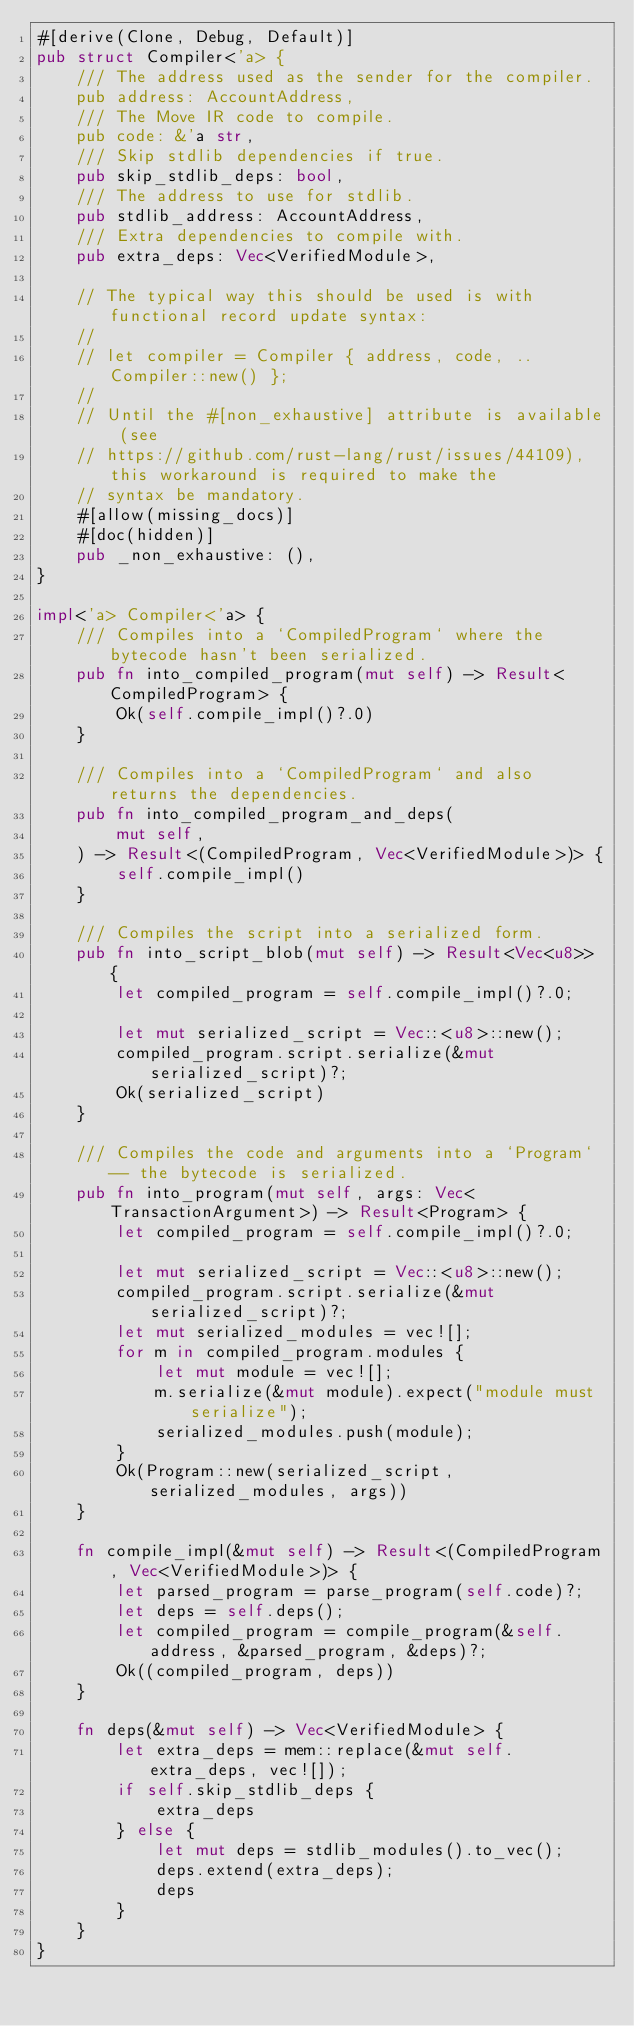<code> <loc_0><loc_0><loc_500><loc_500><_Rust_>#[derive(Clone, Debug, Default)]
pub struct Compiler<'a> {
    /// The address used as the sender for the compiler.
    pub address: AccountAddress,
    /// The Move IR code to compile.
    pub code: &'a str,
    /// Skip stdlib dependencies if true.
    pub skip_stdlib_deps: bool,
    /// The address to use for stdlib.
    pub stdlib_address: AccountAddress,
    /// Extra dependencies to compile with.
    pub extra_deps: Vec<VerifiedModule>,

    // The typical way this should be used is with functional record update syntax:
    //
    // let compiler = Compiler { address, code, ..Compiler::new() };
    //
    // Until the #[non_exhaustive] attribute is available (see
    // https://github.com/rust-lang/rust/issues/44109), this workaround is required to make the
    // syntax be mandatory.
    #[allow(missing_docs)]
    #[doc(hidden)]
    pub _non_exhaustive: (),
}

impl<'a> Compiler<'a> {
    /// Compiles into a `CompiledProgram` where the bytecode hasn't been serialized.
    pub fn into_compiled_program(mut self) -> Result<CompiledProgram> {
        Ok(self.compile_impl()?.0)
    }

    /// Compiles into a `CompiledProgram` and also returns the dependencies.
    pub fn into_compiled_program_and_deps(
        mut self,
    ) -> Result<(CompiledProgram, Vec<VerifiedModule>)> {
        self.compile_impl()
    }

    /// Compiles the script into a serialized form.
    pub fn into_script_blob(mut self) -> Result<Vec<u8>> {
        let compiled_program = self.compile_impl()?.0;

        let mut serialized_script = Vec::<u8>::new();
        compiled_program.script.serialize(&mut serialized_script)?;
        Ok(serialized_script)
    }

    /// Compiles the code and arguments into a `Program` -- the bytecode is serialized.
    pub fn into_program(mut self, args: Vec<TransactionArgument>) -> Result<Program> {
        let compiled_program = self.compile_impl()?.0;

        let mut serialized_script = Vec::<u8>::new();
        compiled_program.script.serialize(&mut serialized_script)?;
        let mut serialized_modules = vec![];
        for m in compiled_program.modules {
            let mut module = vec![];
            m.serialize(&mut module).expect("module must serialize");
            serialized_modules.push(module);
        }
        Ok(Program::new(serialized_script, serialized_modules, args))
    }

    fn compile_impl(&mut self) -> Result<(CompiledProgram, Vec<VerifiedModule>)> {
        let parsed_program = parse_program(self.code)?;
        let deps = self.deps();
        let compiled_program = compile_program(&self.address, &parsed_program, &deps)?;
        Ok((compiled_program, deps))
    }

    fn deps(&mut self) -> Vec<VerifiedModule> {
        let extra_deps = mem::replace(&mut self.extra_deps, vec![]);
        if self.skip_stdlib_deps {
            extra_deps
        } else {
            let mut deps = stdlib_modules().to_vec();
            deps.extend(extra_deps);
            deps
        }
    }
}
</code> 